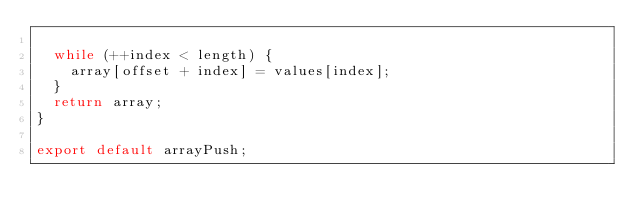<code> <loc_0><loc_0><loc_500><loc_500><_JavaScript_>
  while (++index < length) {
    array[offset + index] = values[index];
  }
  return array;
}

export default arrayPush;
</code> 